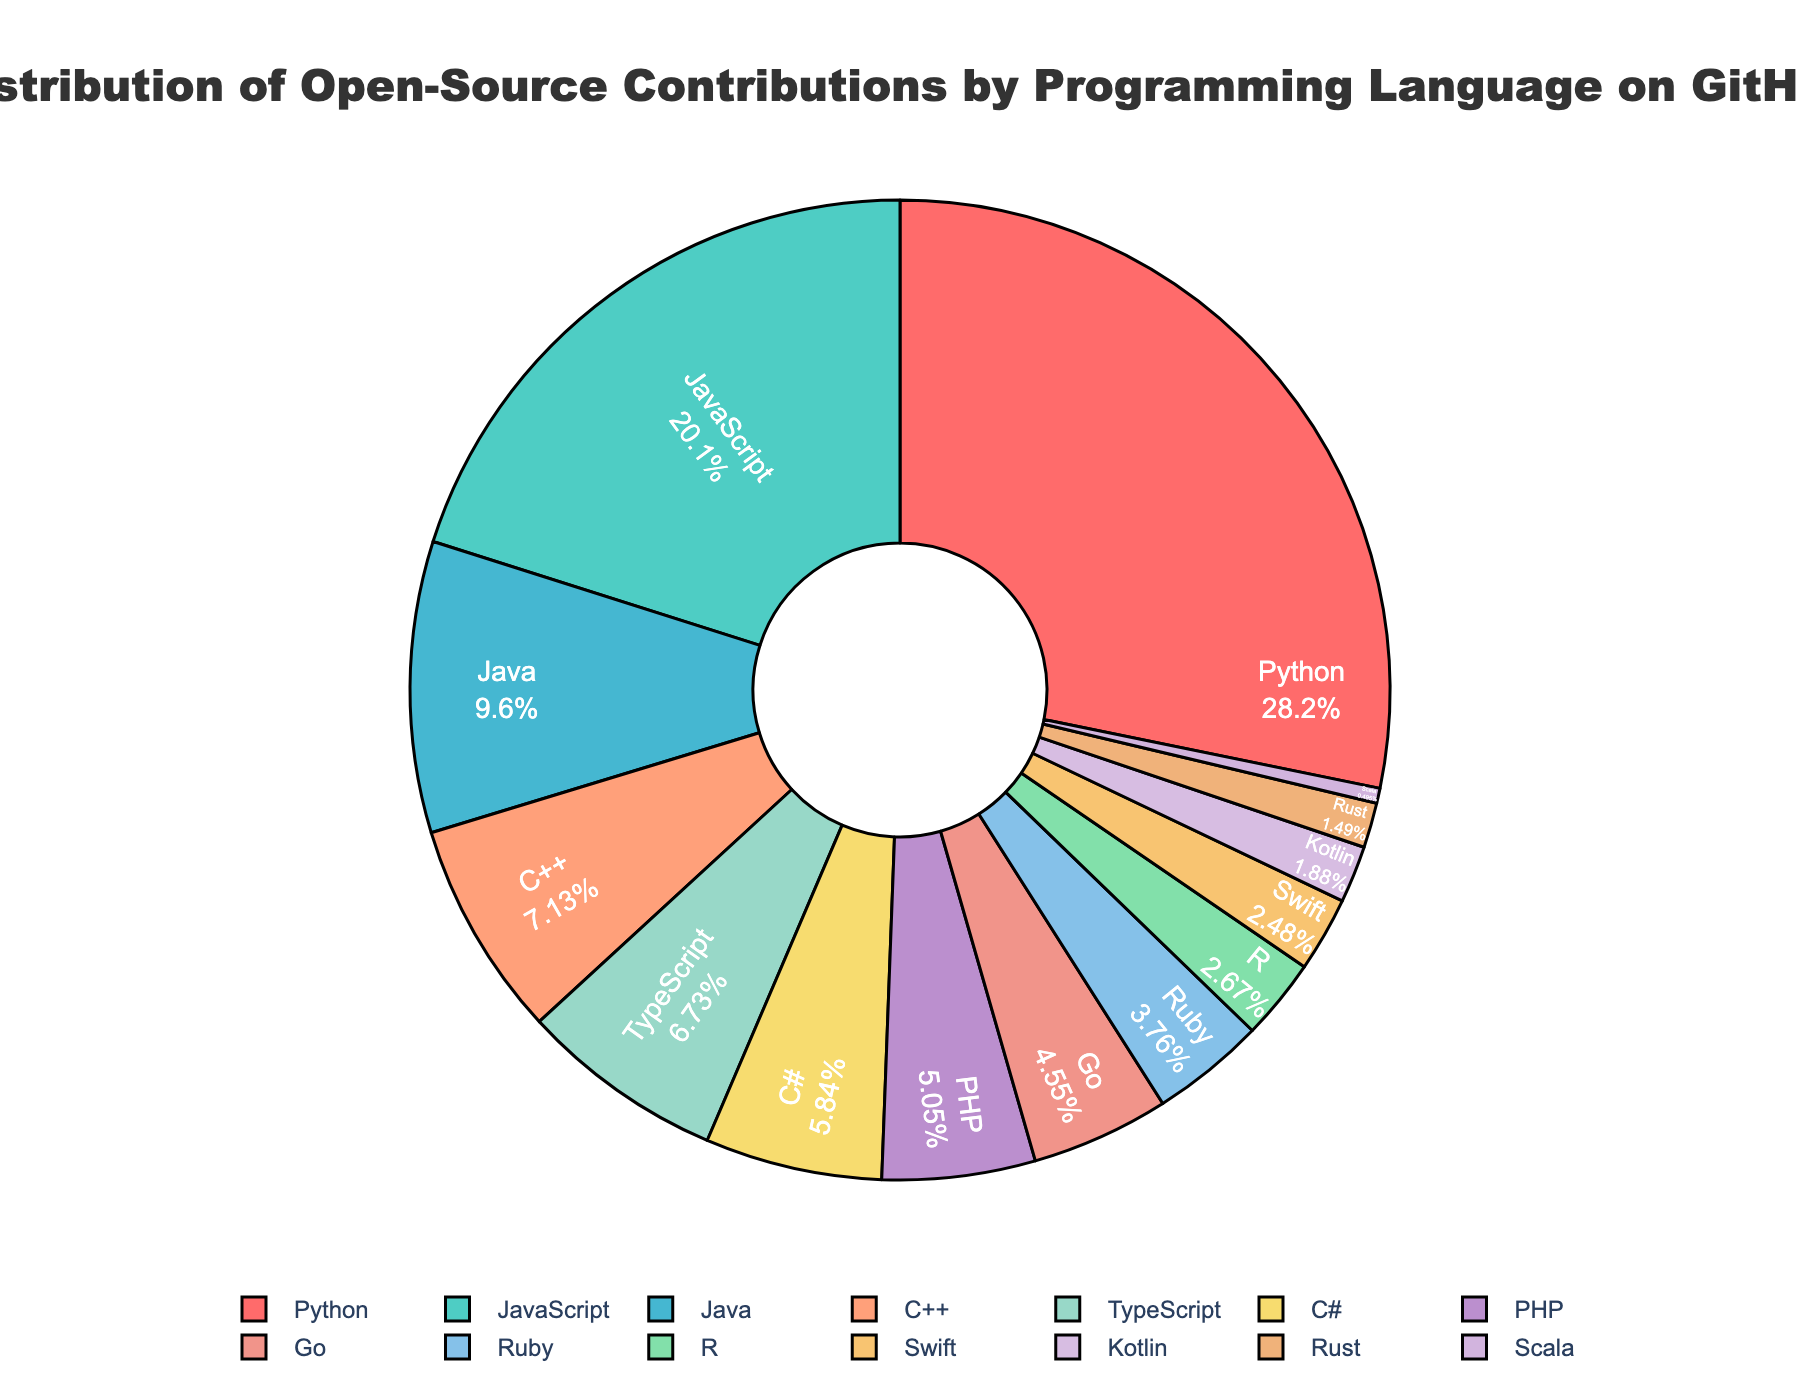What percentage of contributions are made by Python and JavaScript combined? Python contributes 28.5%, and JavaScript contributes 20.3%. Add these two percentages together: 28.5 + 20.3 = 48.8.
Answer: 48.8% Which language contributes the least to open-source projects on GitHub? Scala has the smallest slice on the pie chart with 0.5%.
Answer: Scala Compare the contributions of Java and C++. Which language has a higher percentage, and by how much? Java contributes 9.7%, and C++ contributes 7.2%. The difference between them is 9.7 - 7.2 = 2.5. Java has a higher percentage by 2.5%.
Answer: Java, 2.5% How does the contribution of TypeScript compare to that of C#? TypeScript contributes 6.8%, while C# contributes 5.9%. The difference is 6.8 - 5.9 = 0.9. TypeScript contributes more by 0.9%.
Answer: TypeScript, 0.9% If you combined the contributions of Ruby, R, and Swift, what would be their total percentage? Ruby contributes 3.8%, R contributes 2.7%, and Swift contributes 2.5%. Adding these percentages gives 3.8 + 2.7 + 2.5 = 9.0.
Answer: 9.0% Which language group exceeds 20% contribution listed in the chart? The only languages that exceed 20% in the pie chart are Python with 28.5% and JavaScript with 20.3%.
Answer: Python, JavaScript Compare the contributions of Go and PHP. Which language has a higher contribution and by what percentage? Go contributes 4.6%, and PHP contributes 5.1%. The difference is 5.1 - 4.6 = 0.5. PHP has a higher contribution by 0.5%.
Answer: PHP, 0.5% Among the listed languages, how many contribute between 1% and 5% to open-source projects on GitHub? The languages contributing between 1% and 5% are: Go (4.6%), Ruby (3.8%), R (2.7%), Swift (2.5%), Kotlin (1.9%), and Rust (1.5%). There are 6 such languages.
Answer: 6 What is the color assigned to contributions made by TypeScript in the pie chart? The color associated with TypeScript in the pie chart is identified by looking at the slice labeled "TypeScript," which is visually distinguished using color. In this case, it's shown in a shade of blue.
Answer: Blue 